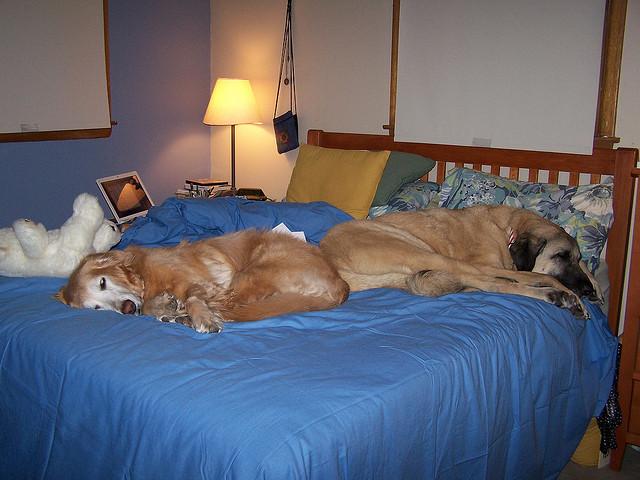Is there a laptop in this picture?
Short answer required. Yes. Are the dogs fighting?
Write a very short answer. No. What color is the comforter?
Answer briefly. Blue. What breed is the dog on the right?
Give a very brief answer. Golden retriever. 